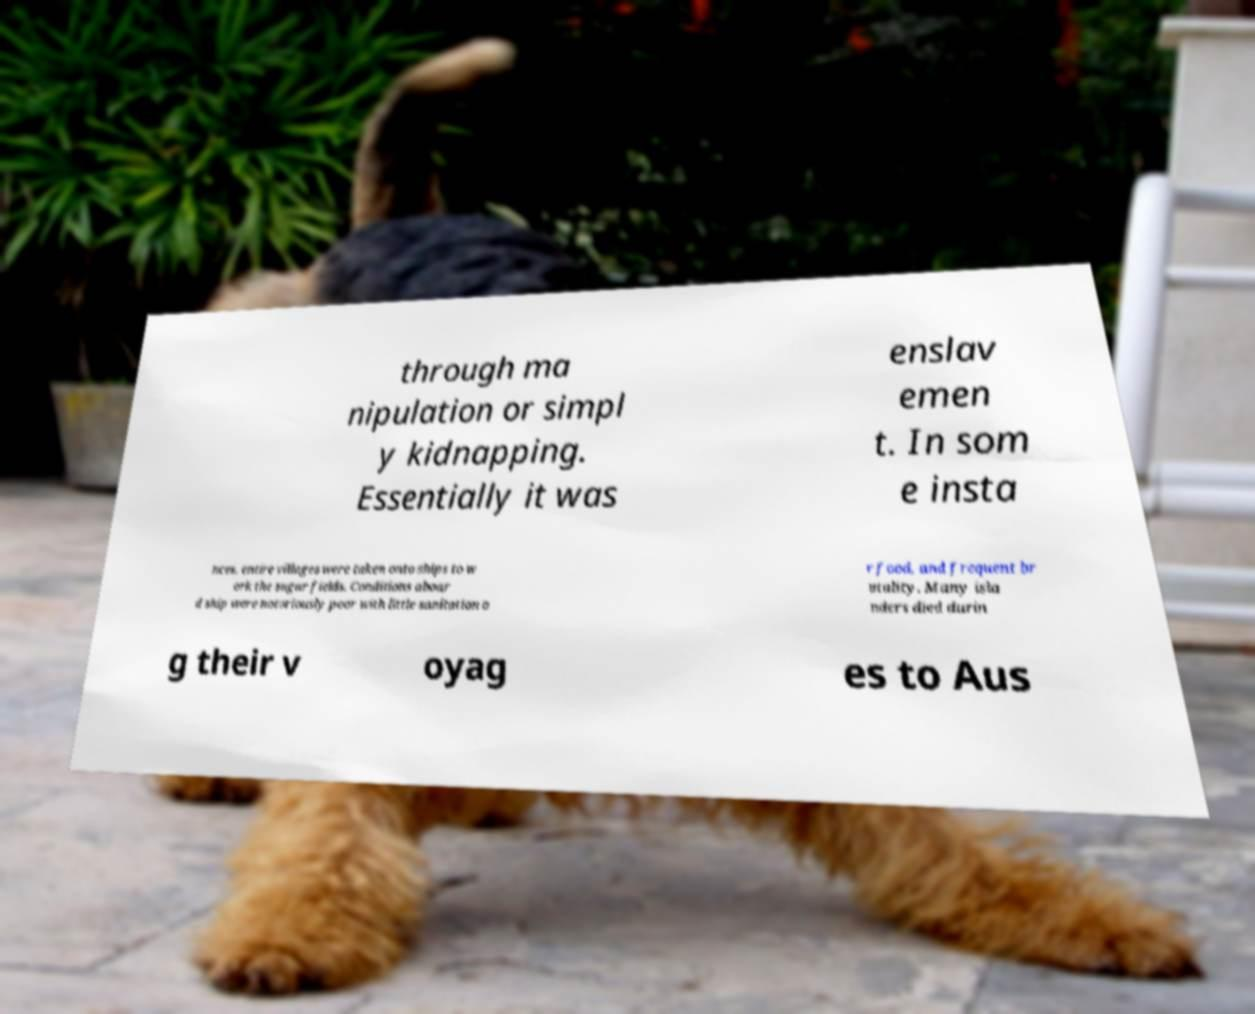Could you assist in decoding the text presented in this image and type it out clearly? through ma nipulation or simpl y kidnapping. Essentially it was enslav emen t. In som e insta nces, entire villages were taken onto ships to w ork the sugar fields. Conditions aboar d ship were notoriously poor with little sanitation o r food, and frequent br utality. Many isla nders died durin g their v oyag es to Aus 